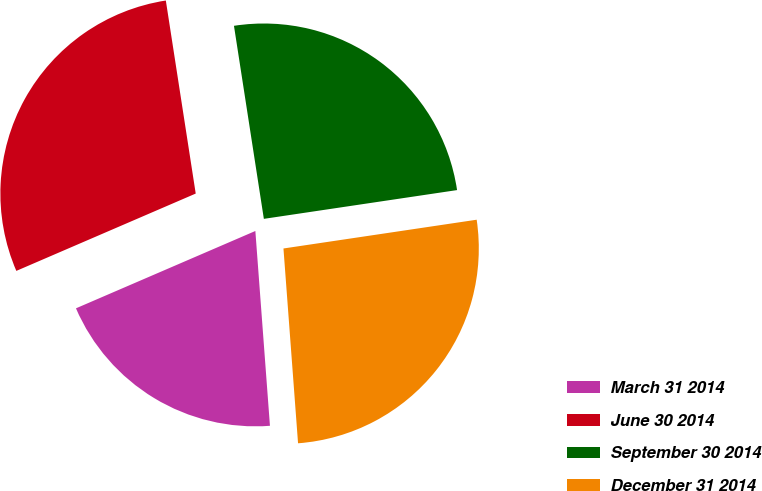<chart> <loc_0><loc_0><loc_500><loc_500><pie_chart><fcel>March 31 2014<fcel>June 30 2014<fcel>September 30 2014<fcel>December 31 2014<nl><fcel>19.71%<fcel>29.03%<fcel>25.09%<fcel>26.16%<nl></chart> 